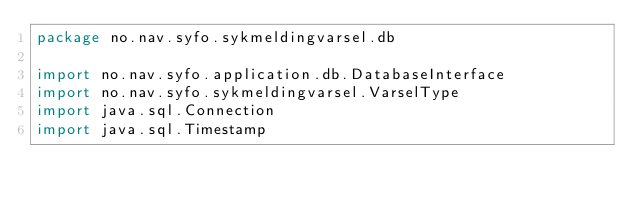Convert code to text. <code><loc_0><loc_0><loc_500><loc_500><_Kotlin_>package no.nav.syfo.sykmeldingvarsel.db

import no.nav.syfo.application.db.DatabaseInterface
import no.nav.syfo.sykmeldingvarsel.VarselType
import java.sql.Connection
import java.sql.Timestamp
</code> 